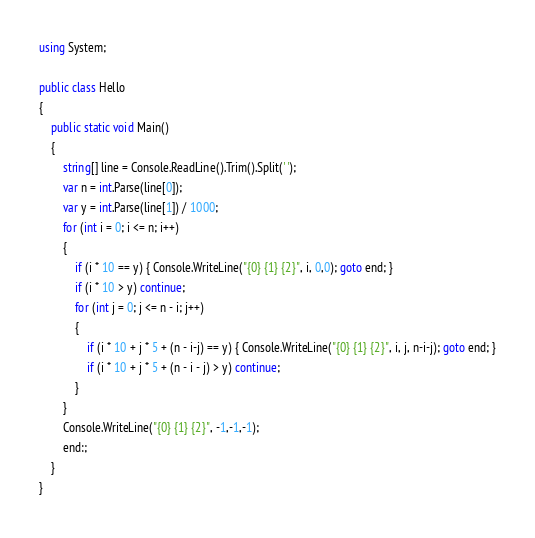<code> <loc_0><loc_0><loc_500><loc_500><_C#_>using System;

public class Hello
{
    public static void Main()
    {
        string[] line = Console.ReadLine().Trim().Split(' ');
        var n = int.Parse(line[0]);
        var y = int.Parse(line[1]) / 1000;
        for (int i = 0; i <= n; i++)
        {
            if (i * 10 == y) { Console.WriteLine("{0} {1} {2}", i, 0,0); goto end; }
            if (i * 10 > y) continue;
            for (int j = 0; j <= n - i; j++)
            {
                if (i * 10 + j * 5 + (n - i-j) == y) { Console.WriteLine("{0} {1} {2}", i, j, n-i-j); goto end; }
                if (i * 10 + j * 5 + (n - i - j) > y) continue;
            }
        }
        Console.WriteLine("{0} {1} {2}", -1,-1,-1);
        end:;
    }
}</code> 